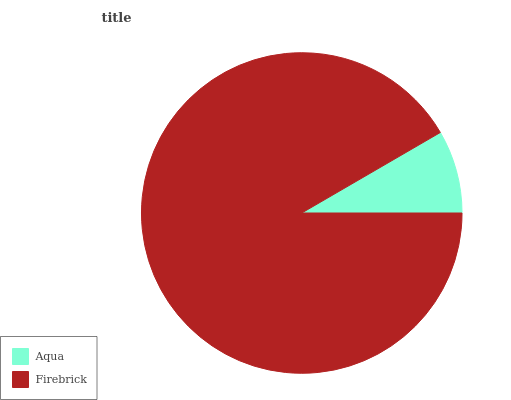Is Aqua the minimum?
Answer yes or no. Yes. Is Firebrick the maximum?
Answer yes or no. Yes. Is Firebrick the minimum?
Answer yes or no. No. Is Firebrick greater than Aqua?
Answer yes or no. Yes. Is Aqua less than Firebrick?
Answer yes or no. Yes. Is Aqua greater than Firebrick?
Answer yes or no. No. Is Firebrick less than Aqua?
Answer yes or no. No. Is Firebrick the high median?
Answer yes or no. Yes. Is Aqua the low median?
Answer yes or no. Yes. Is Aqua the high median?
Answer yes or no. No. Is Firebrick the low median?
Answer yes or no. No. 